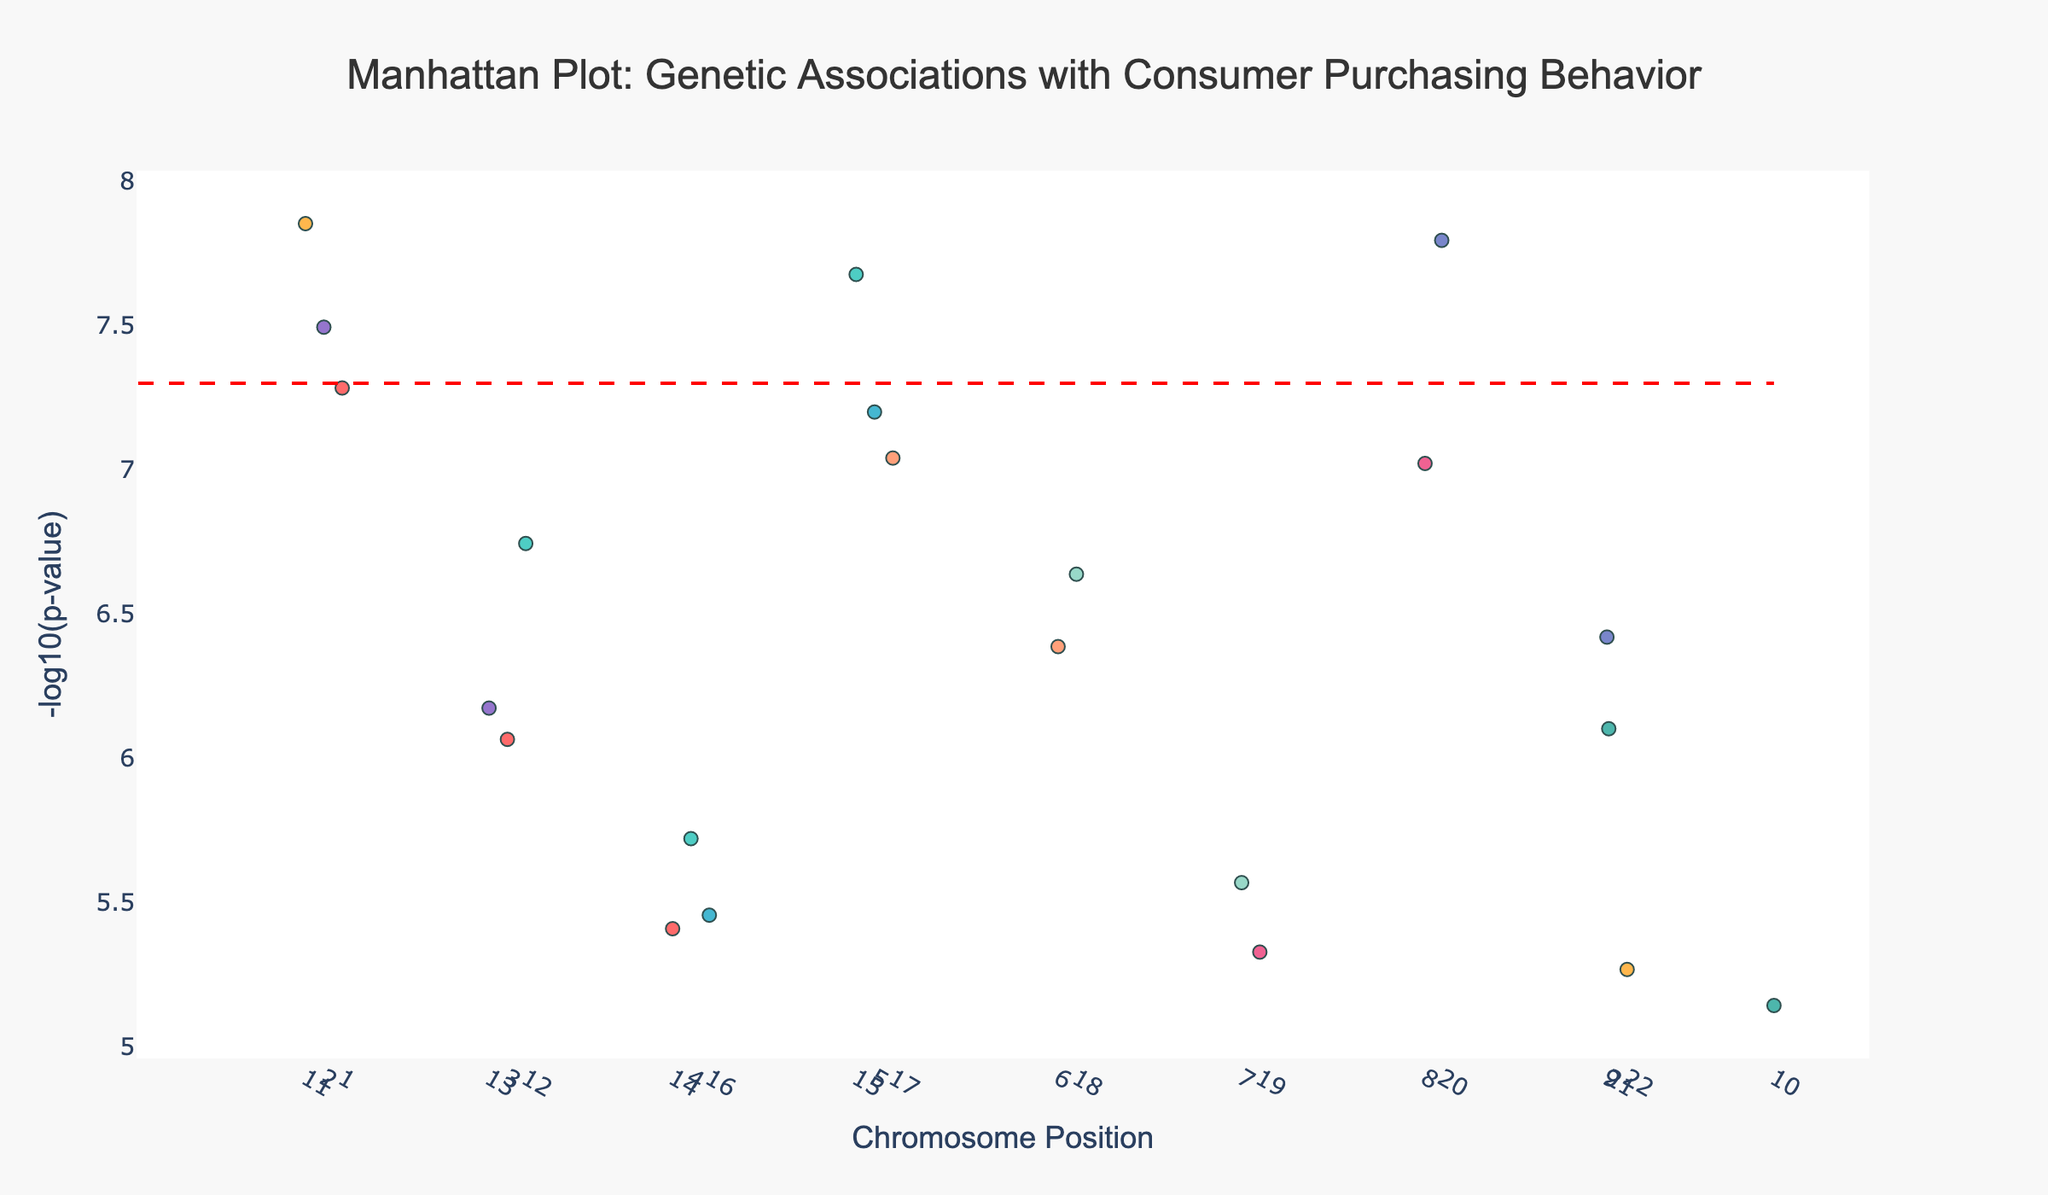How many data points are displayed in the plot? To find the number of data points, count the number of genetic associations shown as markers in the plot. This can be directly observed by reviewing each point on the plot.
Answer: 22 What is the title of the plot? The title of the plot is generally displayed at the top center and summarizes the primary insight or purpose of the plot. In this case, it states what the plot is depicting.
Answer: "Manhattan Plot: Genetic Associations with Consumer Purchasing Behavior" Which chromosome has the highest peak in terms of -log10(p-value)? Identify the peak values of each chromosome by looking for the highest points. The chromosome with the point having the highest y-axis value is the answer. In this plot, the comparison shows that Chromosome 1 has the highest point.
Answer: Chromosome 1 Which gene has the smallest p-value for its association with a product category? The smallest p-value corresponds to the highest -log10(p-value). Look for the highest point on the y-axis and identify its associated gene label.
Answer: OPRM1 What is the significance threshold indicated by the red dashed line? The red dashed line represents the significance threshold, which is typically set at a specific -log10(p-value). Find where the red line intersects the y-axis to determine this value.
Answer: 7.3 How many genes have a -log10(p-value) greater than the significance threshold? Count the number of points that lie above the red dashed line on the y-axis, indicating a -log10(p-value) greater than the significance threshold.
Answer: 8 Which product category is associated with the gene BDNF? Locate the gene BDNF on the plot and note the associated product category indicated in the hover text.
Answer: Clothing What is the -log10(p-value) of the gene SLC6A3? Identify the position of the gene SLC6A3 on the plot and read its corresponding y-axis value (-log10(p-value)).
Answer: 8.85 Compare the -log10(p-value) of genes DRD2 and MAOA. Which one has a higher value? Find the points corresponding to genes DRD2 and MAOA. Compare their y-axis values (-log10(p-value)) to determine which is higher.
Answer: DRD2 What product categories are associated with genes having a -log10(p-value) less than 6? Identify the genes with y-axis values (-log10(p-value)) less than 6. Check the hover text for these genes to note their associated product categories.
Answer: Beauty Products, Office Supplies, Pet Supplies, Travel Accessories, Jewelry, Music Instruments, Stationery 